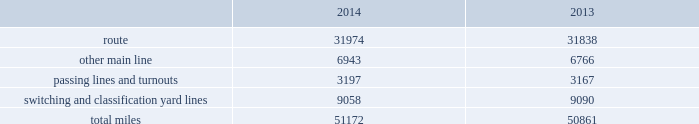Item 1b .
Unresolved staff comments item 2 .
Properties we employ a variety of assets in the management and operation of our rail business .
Our rail network covers 23 states in the western two-thirds of the u.s .
Our rail network includes 31974 route miles .
We own 26012 miles and operate on the remainder pursuant to trackage rights or leases .
The table describes track miles at december 31 , 2014 and 2013 .
2014 2013 .
Headquarters building we own our headquarters building in omaha , nebraska .
The facility has 1.2 million square feet of space for approximately 4000 employees. .
Assuming an average prison cell is 230 square feet , do the headquarters employees have more space than the average prisoner? 
Computations: (((1.2 * 1000000) / 4000) > (230 * 10))
Answer: no. Item 1b .
Unresolved staff comments item 2 .
Properties we employ a variety of assets in the management and operation of our rail business .
Our rail network covers 23 states in the western two-thirds of the u.s .
Our rail network includes 31974 route miles .
We own 26012 miles and operate on the remainder pursuant to trackage rights or leases .
The table describes track miles at december 31 , 2014 and 2013 .
2014 2013 .
Headquarters building we own our headquarters building in omaha , nebraska .
The facility has 1.2 million square feet of space for approximately 4000 employees. .
What percentage of total miles were other main line in 2013? 
Computations: (6766 / 50861)
Answer: 0.13303. 